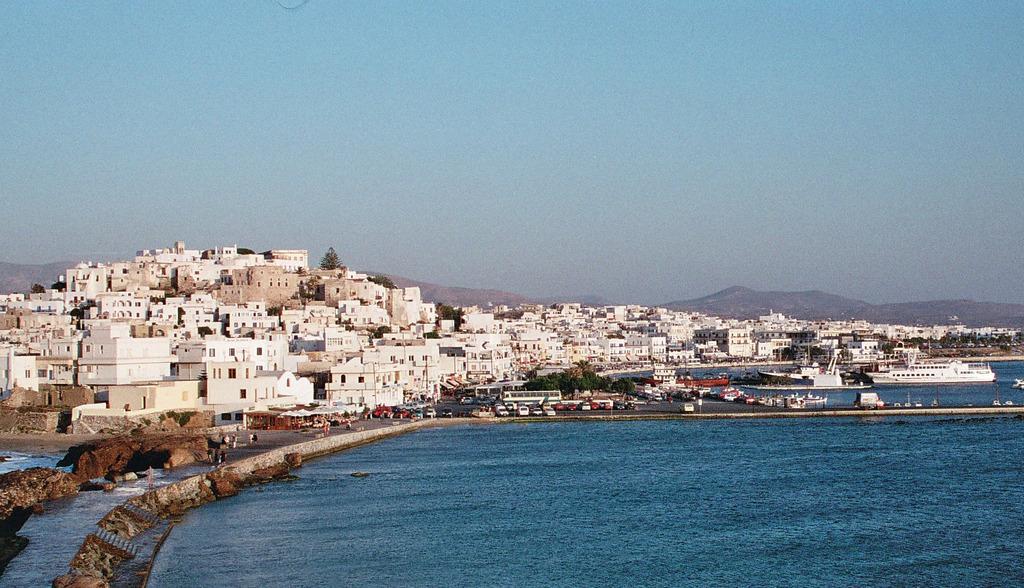In one or two sentences, can you explain what this image depicts? In this picture we can see water, beside the water we can see vehicles on the ground, here we can see ships, boats, trees and in the background we can see buildings, mountains and sky. 